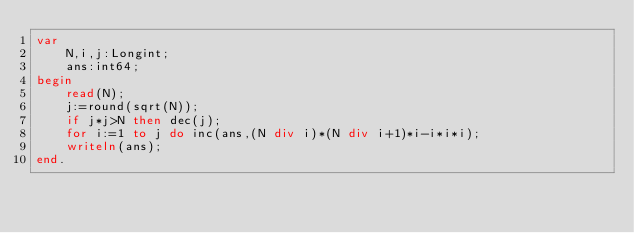<code> <loc_0><loc_0><loc_500><loc_500><_Pascal_>var
	N,i,j:Longint;
	ans:int64;
begin
	read(N);
	j:=round(sqrt(N));
	if j*j>N then dec(j);
	for i:=1 to j do inc(ans,(N div i)*(N div i+1)*i-i*i*i);
	writeln(ans);
end.</code> 